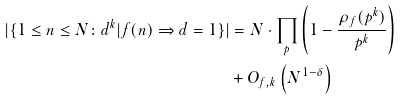<formula> <loc_0><loc_0><loc_500><loc_500>| \{ 1 \leq n \leq N \colon d ^ { k } | f ( n ) \Rightarrow d = 1 \} | & = N \cdot \prod _ { p } \left ( 1 - \frac { \rho _ { f } ( p ^ { k } ) } { p ^ { k } } \right ) \\ & + O _ { f , k } \left ( N ^ { 1 - \delta } \right )</formula> 